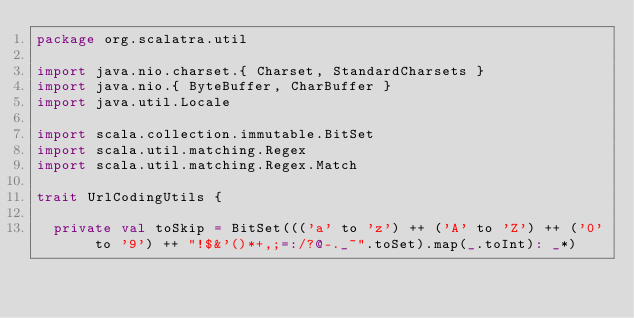Convert code to text. <code><loc_0><loc_0><loc_500><loc_500><_Scala_>package org.scalatra.util

import java.nio.charset.{ Charset, StandardCharsets }
import java.nio.{ ByteBuffer, CharBuffer }
import java.util.Locale

import scala.collection.immutable.BitSet
import scala.util.matching.Regex
import scala.util.matching.Regex.Match

trait UrlCodingUtils {

  private val toSkip = BitSet((('a' to 'z') ++ ('A' to 'Z') ++ ('0' to '9') ++ "!$&'()*+,;=:/?@-._~".toSet).map(_.toInt): _*)</code> 